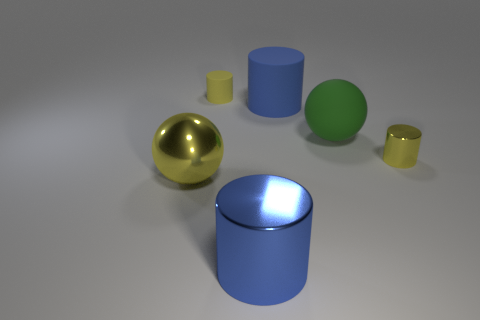Subtract all yellow metallic cylinders. How many cylinders are left? 3 Subtract all blue cylinders. How many cylinders are left? 2 Add 3 yellow objects. How many objects exist? 9 Subtract all purple cylinders. Subtract all brown balls. How many cylinders are left? 4 Add 5 large blue rubber cylinders. How many large blue rubber cylinders exist? 6 Subtract 0 gray cubes. How many objects are left? 6 Subtract all balls. How many objects are left? 4 Subtract 2 spheres. How many spheres are left? 0 Subtract all purple blocks. How many yellow spheres are left? 1 Subtract all blue metallic things. Subtract all big cylinders. How many objects are left? 3 